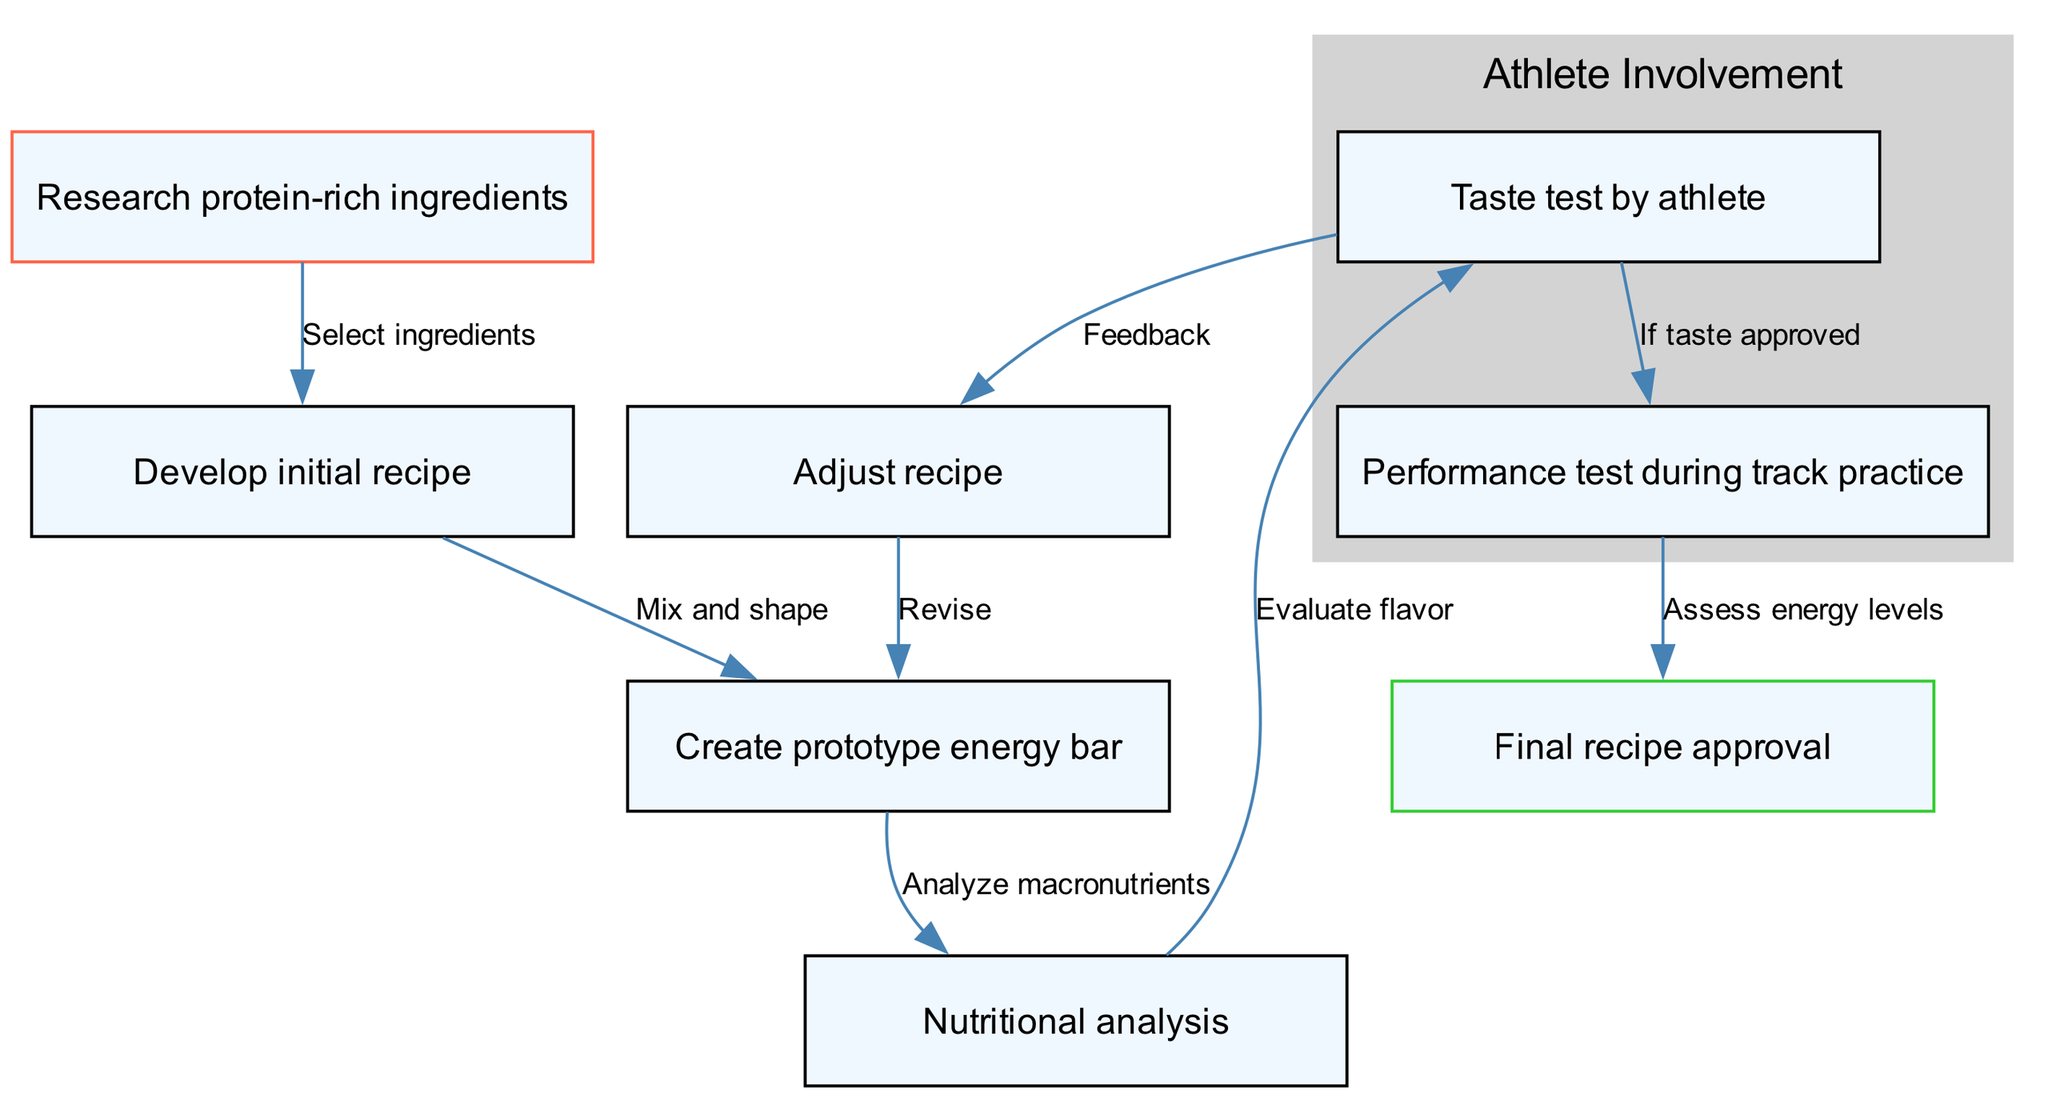What is the first step in the process? The first step, represented by node 1, is "Research protein-rich ingredients". This is identified by looking for the initial node in the diagram that does not have any incoming edges.
Answer: Research protein-rich ingredients How many nodes are present in the diagram? The total number of nodes can be determined by counting each unique step or stage in the process, which is listed in the nodes section. There are 8 nodes in total.
Answer: 8 What is the last step in the process? The last step, represented by node 8, is "Final recipe approval". This is found by identifying the node with no outgoing edges, indicating it is the endpoint of the process.
Answer: Final recipe approval What follows after creating the prototype energy bar? Once the "Create prototype energy bar" step (node 3) is completed, the subsequent step is "Nutritional analysis" (node 4), which can be traced along the directed edge connecting those two nodes.
Answer: Nutritional analysis How many times is the recipe adjusted based on taste testing? The diagram indicates that the recipe is adjusted once, where the feedback from the taste test leads to the "Adjust recipe" step (node 6). This is depicted from node 5 to node 6 in the process flow.
Answer: 1 What is the relationship between taste testing and performance testing? The relationship shows that if the taste test by an athlete (node 5) is approved, then the next step is "Performance test during track practice" (node 7), indicating a conditional flow from one process to another.
Answer: If taste approved Which node is colored green? The end node, "Final recipe approval", is colored green indicating it is the concluding step of the process in the diagram. This is identified by checking the node colors as specified in the graph settings.
Answer: Final recipe approval What action is taken after feedback from taste testing? After receiving feedback from the taste test (node 5), the action taken is to "Adjust recipe" (node 6), as shown by the directed edge leading to that node.
Answer: Adjust recipe 